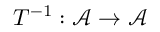<formula> <loc_0><loc_0><loc_500><loc_500>T ^ { - 1 } \colon { \mathcal { A } } \to { \mathcal { A } }</formula> 